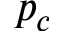Convert formula to latex. <formula><loc_0><loc_0><loc_500><loc_500>p _ { c }</formula> 